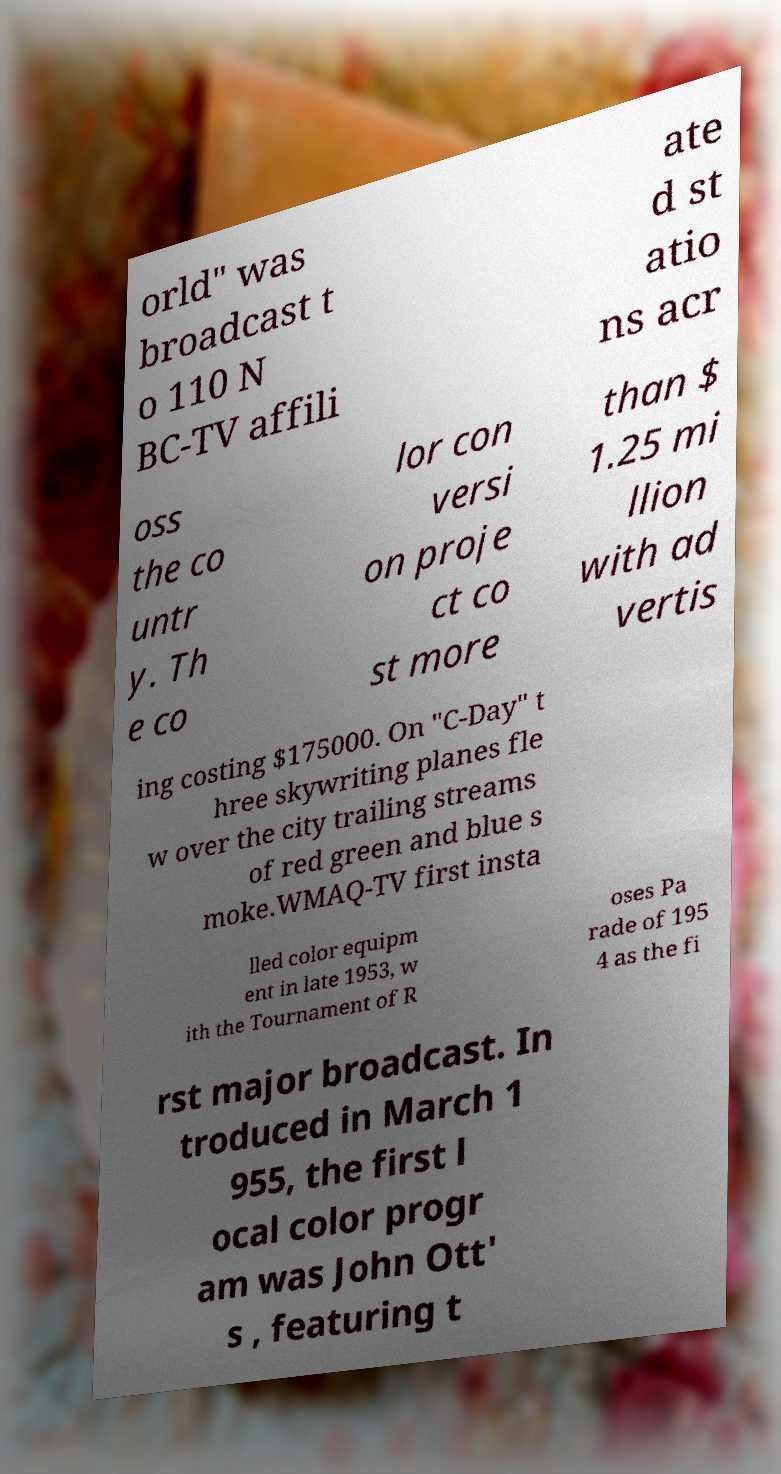I need the written content from this picture converted into text. Can you do that? orld" was broadcast t o 110 N BC-TV affili ate d st atio ns acr oss the co untr y. Th e co lor con versi on proje ct co st more than $ 1.25 mi llion with ad vertis ing costing $175000. On "C-Day" t hree skywriting planes fle w over the city trailing streams of red green and blue s moke.WMAQ-TV first insta lled color equipm ent in late 1953, w ith the Tournament of R oses Pa rade of 195 4 as the fi rst major broadcast. In troduced in March 1 955, the first l ocal color progr am was John Ott' s , featuring t 